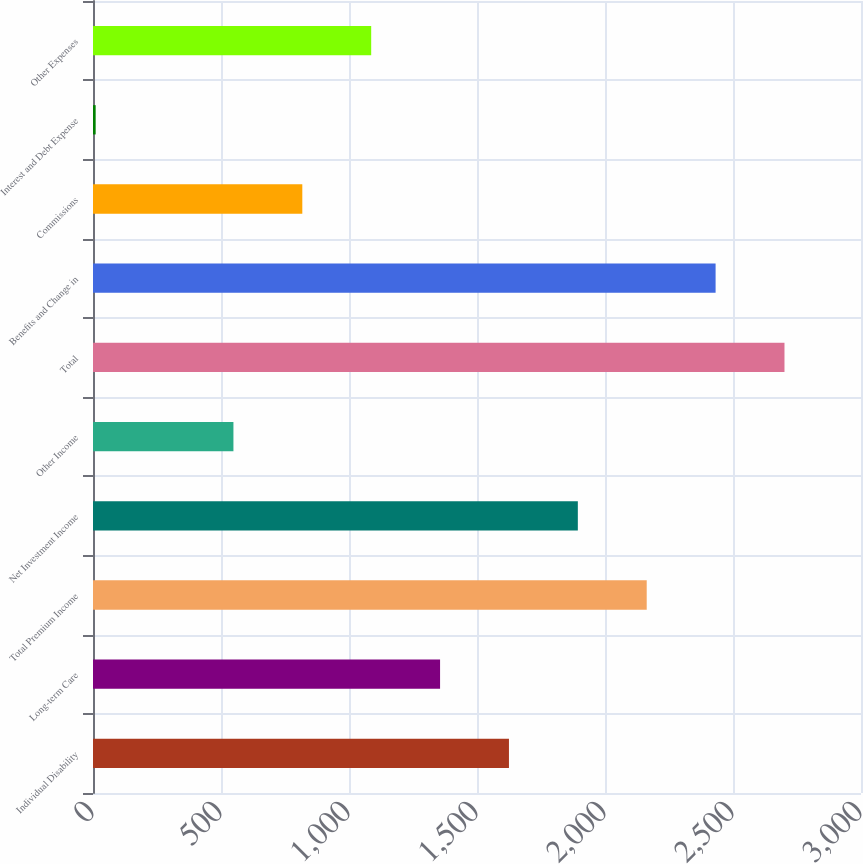Convert chart to OTSL. <chart><loc_0><loc_0><loc_500><loc_500><bar_chart><fcel>Individual Disability<fcel>Long-term Care<fcel>Total Premium Income<fcel>Net Investment Income<fcel>Other Income<fcel>Total<fcel>Benefits and Change in<fcel>Commissions<fcel>Interest and Debt Expense<fcel>Other Expenses<nl><fcel>1624.82<fcel>1355.75<fcel>2162.96<fcel>1893.89<fcel>548.54<fcel>2701.1<fcel>2432.03<fcel>817.61<fcel>10.4<fcel>1086.68<nl></chart> 